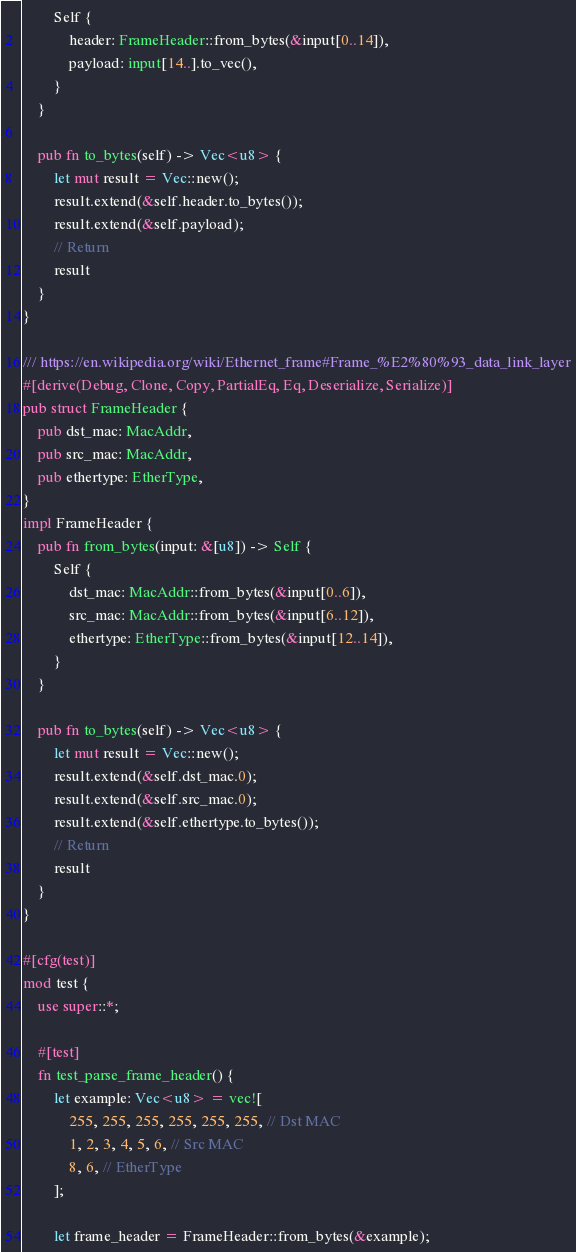Convert code to text. <code><loc_0><loc_0><loc_500><loc_500><_Rust_>        Self {
            header: FrameHeader::from_bytes(&input[0..14]),
            payload: input[14..].to_vec(),
        }
    }

    pub fn to_bytes(self) -> Vec<u8> {
        let mut result = Vec::new();
        result.extend(&self.header.to_bytes());
        result.extend(&self.payload);
        // Return
        result
    }
}

/// https://en.wikipedia.org/wiki/Ethernet_frame#Frame_%E2%80%93_data_link_layer
#[derive(Debug, Clone, Copy, PartialEq, Eq, Deserialize, Serialize)]
pub struct FrameHeader {
    pub dst_mac: MacAddr,
    pub src_mac: MacAddr,
    pub ethertype: EtherType,
}
impl FrameHeader {
    pub fn from_bytes(input: &[u8]) -> Self {
        Self {
            dst_mac: MacAddr::from_bytes(&input[0..6]),
            src_mac: MacAddr::from_bytes(&input[6..12]),
            ethertype: EtherType::from_bytes(&input[12..14]),
        }
    }

    pub fn to_bytes(self) -> Vec<u8> {
        let mut result = Vec::new();
        result.extend(&self.dst_mac.0);
        result.extend(&self.src_mac.0);
        result.extend(&self.ethertype.to_bytes());
        // Return
        result
    }
}

#[cfg(test)]
mod test {
    use super::*;

    #[test]
    fn test_parse_frame_header() {
        let example: Vec<u8> = vec![
            255, 255, 255, 255, 255, 255, // Dst MAC
            1, 2, 3, 4, 5, 6, // Src MAC
            8, 6, // EtherType
        ];

        let frame_header = FrameHeader::from_bytes(&example);</code> 